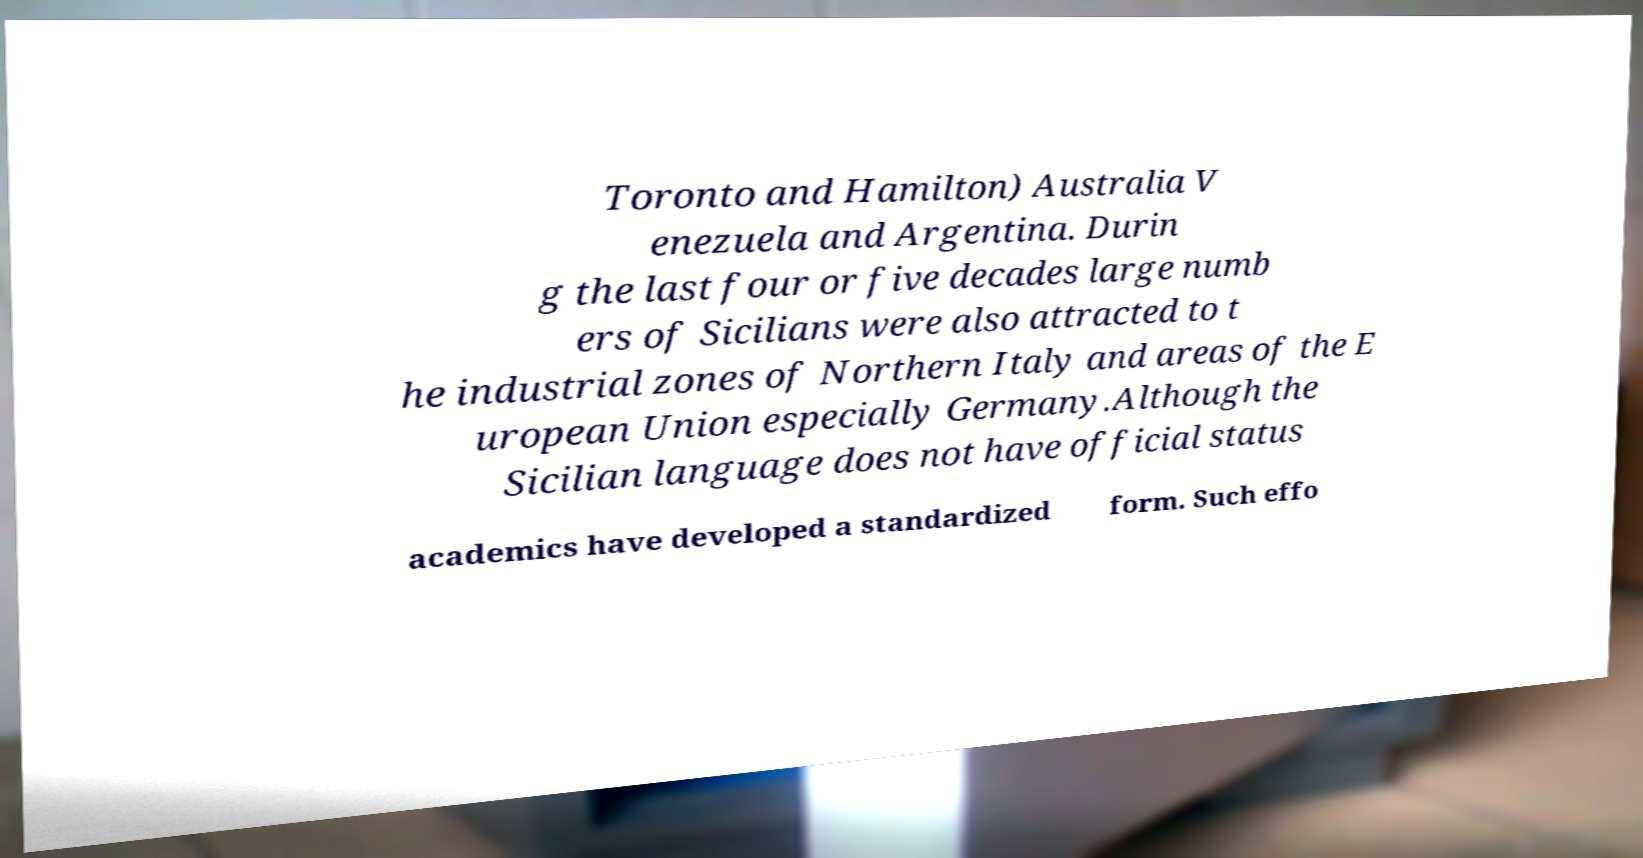For documentation purposes, I need the text within this image transcribed. Could you provide that? Toronto and Hamilton) Australia V enezuela and Argentina. Durin g the last four or five decades large numb ers of Sicilians were also attracted to t he industrial zones of Northern Italy and areas of the E uropean Union especially Germany.Although the Sicilian language does not have official status academics have developed a standardized form. Such effo 